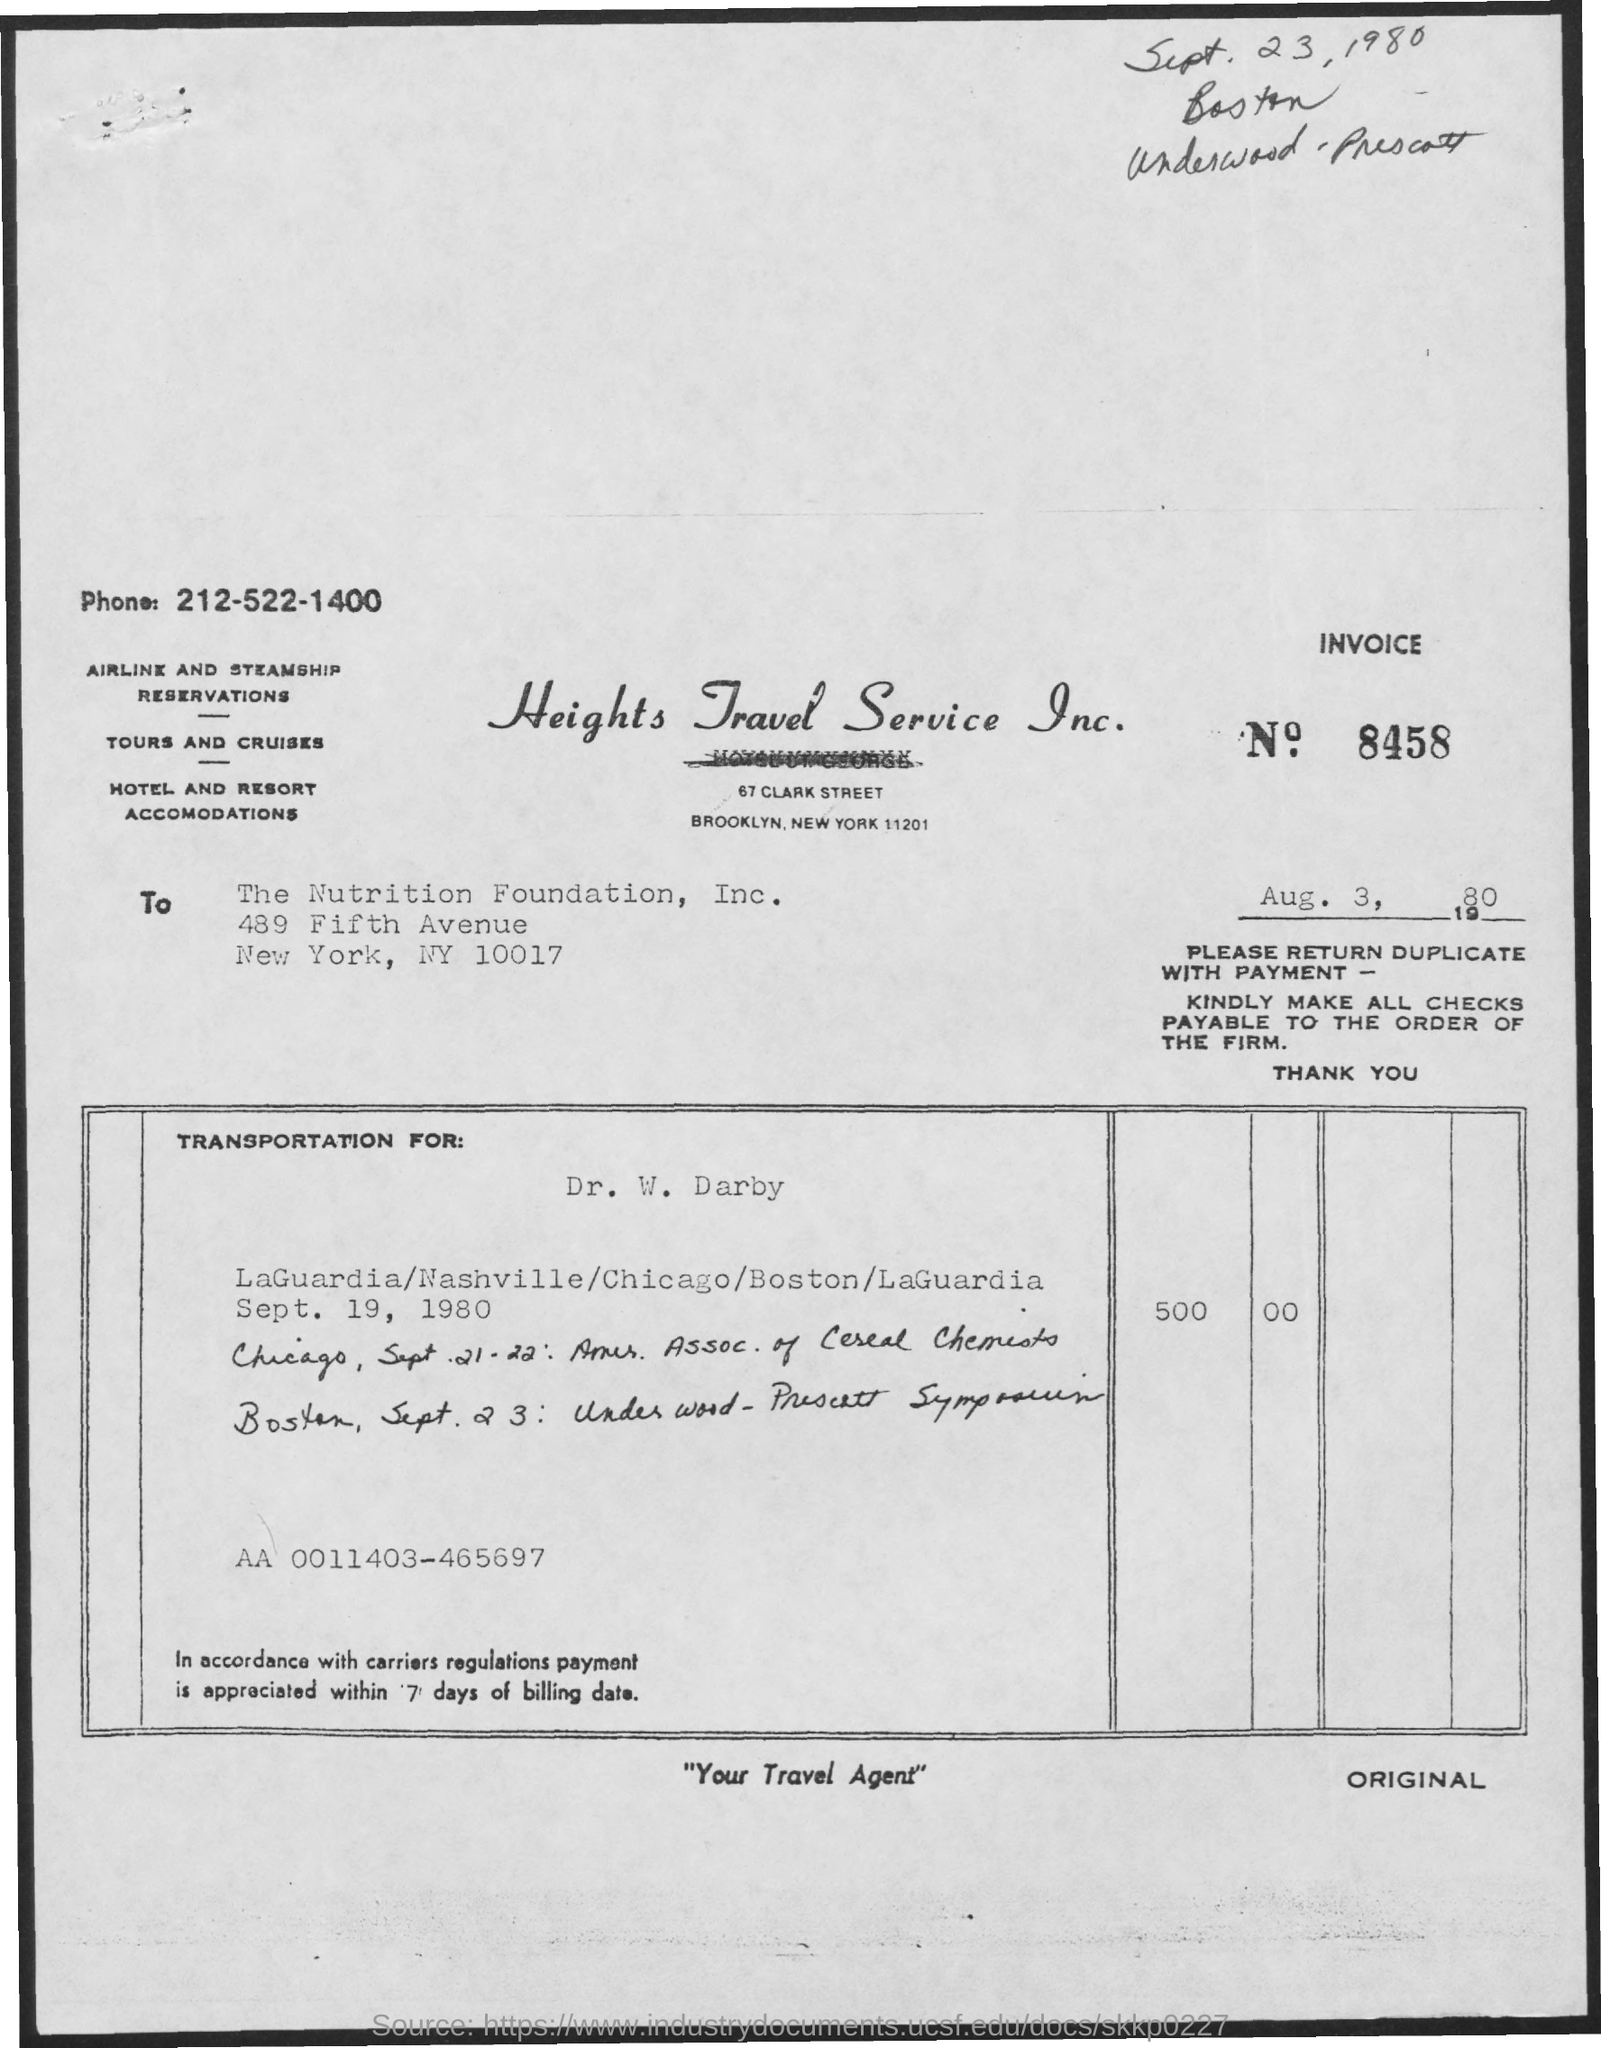List a handful of essential elements in this visual. The invoice number mentioned in the given form is 8458. The phone number mentioned in the given letter is 212-522-1400. The date mentioned in the given letter is August 3, 1980. 